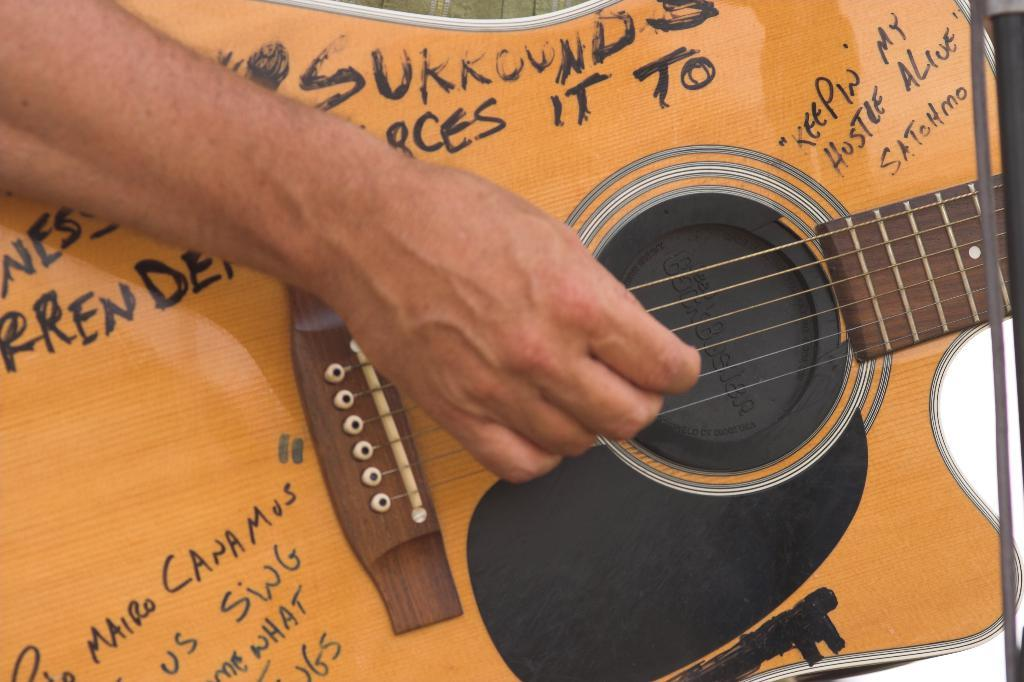What musical instrument is present in the image? There is a guitar in the image. What part of the guitar is being touched in the image? A hand is on the strings of the guitar. How does the guitar compare to a bike in the image? There is no bike present in the image, so it is not possible to make a comparison between the guitar and a bike. 